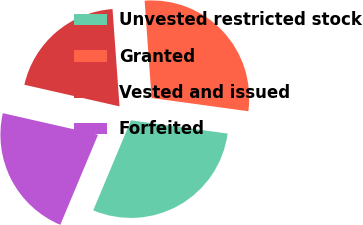<chart> <loc_0><loc_0><loc_500><loc_500><pie_chart><fcel>Unvested restricted stock<fcel>Granted<fcel>Vested and issued<fcel>Forfeited<nl><fcel>29.15%<fcel>28.31%<fcel>20.3%<fcel>22.24%<nl></chart> 